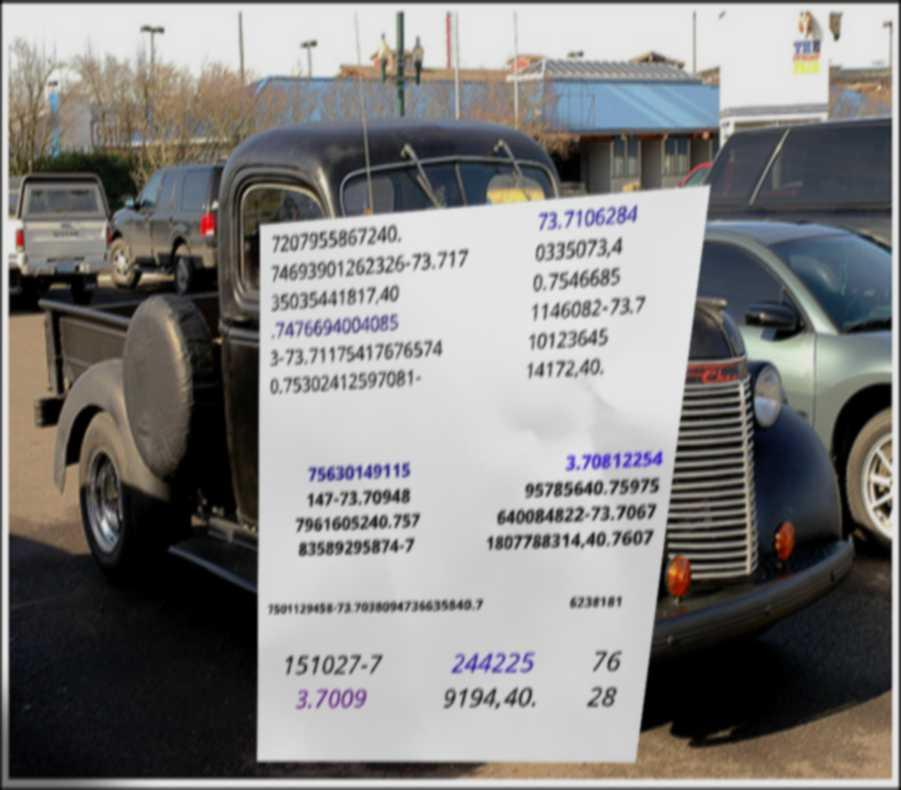Could you extract and type out the text from this image? 7207955867240. 74693901262326-73.717 35035441817,40 .7476694004085 3-73.71175417676574 0.75302412597081- 73.7106284 0335073,4 0.7546685 1146082-73.7 10123645 14172,40. 75630149115 147-73.70948 7961605240.757 83589295874-7 3.70812254 95785640.75975 640084822-73.7067 1807788314,40.7607 7501129458-73.7038094736635840.7 6238181 151027-7 3.7009 244225 9194,40. 76 28 